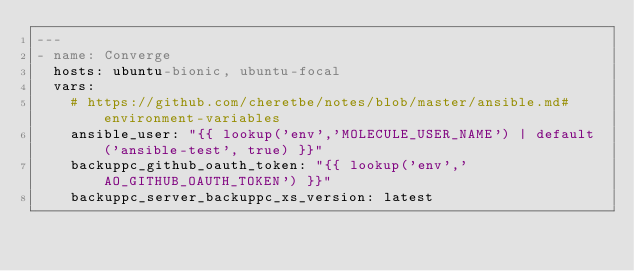<code> <loc_0><loc_0><loc_500><loc_500><_YAML_>---
- name: Converge
  hosts: ubuntu-bionic, ubuntu-focal
  vars:
    # https://github.com/cheretbe/notes/blob/master/ansible.md#environment-variables
    ansible_user: "{{ lookup('env','MOLECULE_USER_NAME') | default('ansible-test', true) }}"
    backuppc_github_oauth_token: "{{ lookup('env','AO_GITHUB_OAUTH_TOKEN') }}"
    backuppc_server_backuppc_xs_version: latest</code> 